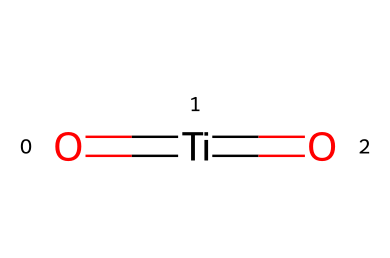what is the central atom in this chemical structure? The central atom is identified by being bonded to the oxygen atoms. In the SMILES representation, the titanium atom (Ti) is the central atom surrounded by two oxygen atoms that form double bonds with it.
Answer: titanium how many oxygen atoms are present in this chemical? By examining the chemical structure, there are two oxygen atoms present. Both oxygen atoms are bonded to the titanium atom in the form of double bonds, as indicated by the structure.
Answer: two what is the oxidation state of titanium in this compound? The oxidation state can be determined by considering the bonding in the structure. Titanium typically has an oxidation state of +4 when bonded to two oxygen atoms with double bonds, as in this case (O2-). Hence, the oxidation state of titanium here is +4.
Answer: +4 what is the overall charge of this chemical compound? The overall charge is determined by considering the oxidation states and the typical charges of the constituent atoms. In this structure, titanium is +4 and each oxygen is -2, leading to a total charge of 0. Thus, the compound is neutral overall.
Answer: neutral what type of bonding is present between the titanium and oxygen atoms? The bonding is characterized by the presence of double bonds between titanium and the oxygen atoms, indicating covalent bonding. This type of bonding involves the sharing of electron pairs between the involved atoms.
Answer: covalent how does the arrangement of atoms contribute to the self-cleaning properties of titanium dioxide? The arrangement of titanium and oxygen contributes to the photocatalytic properties of titanium dioxide, allowing it to break down organic pollutants when exposed to UV light, which is a key aspect of its self-cleaning capabilities.
Answer: photocatalytic properties 